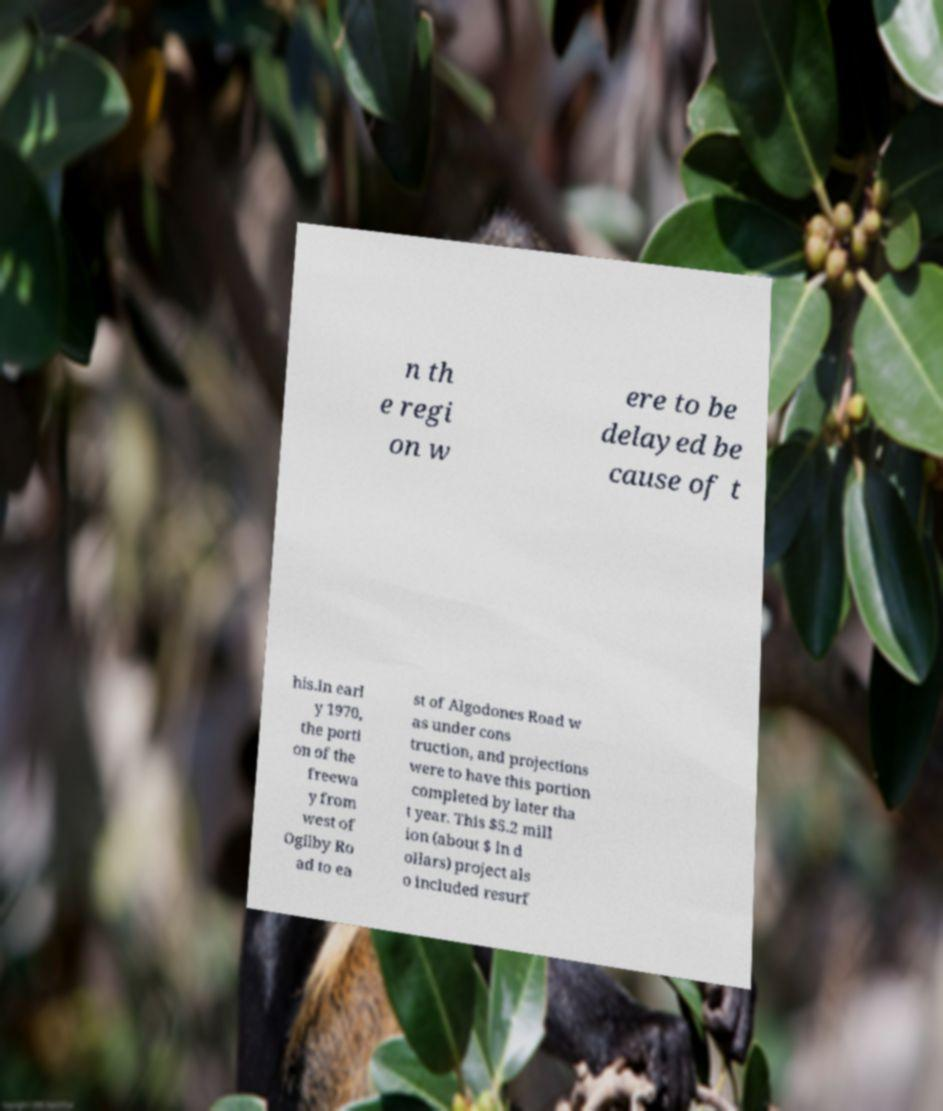Could you extract and type out the text from this image? n th e regi on w ere to be delayed be cause of t his.In earl y 1970, the porti on of the freewa y from west of Ogilby Ro ad to ea st of Algodones Road w as under cons truction, and projections were to have this portion completed by later tha t year. This $5.2 mill ion (about $ in d ollars) project als o included resurf 